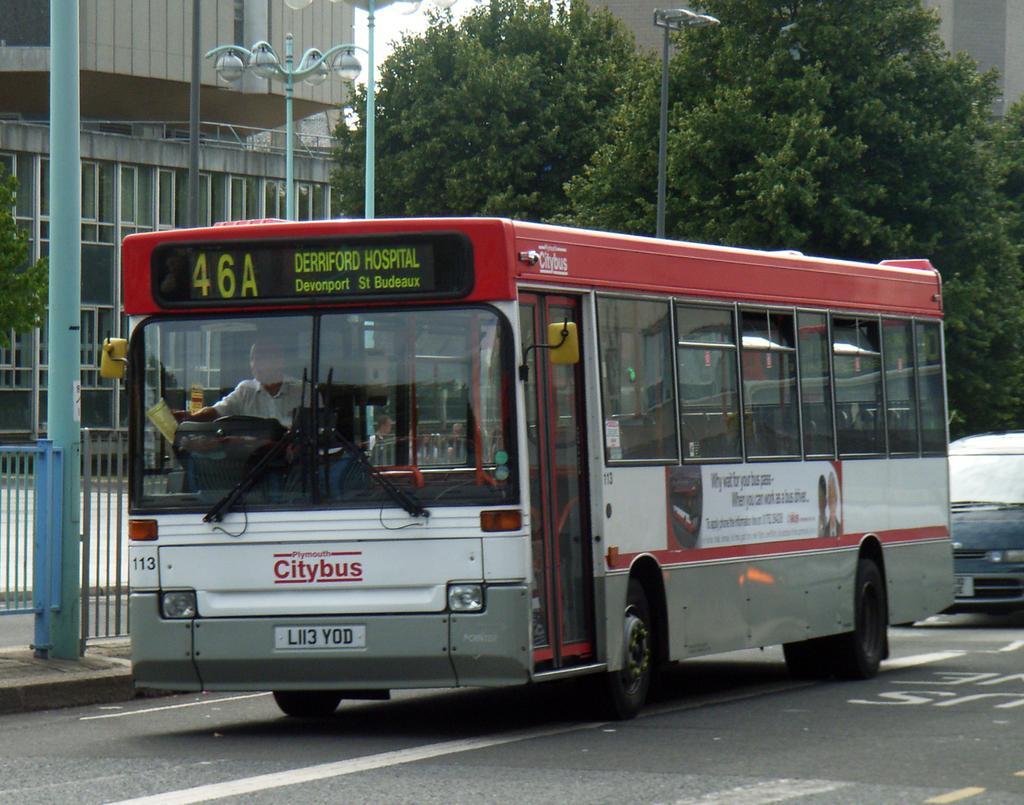Can you describe this image briefly? In this image I can see a white and red colour bus and in it I can see a man. I can also see, on this bus something is written. In background I can see few poles, street lights, few trees, buildings, road, a car and I can see white lines on road. 